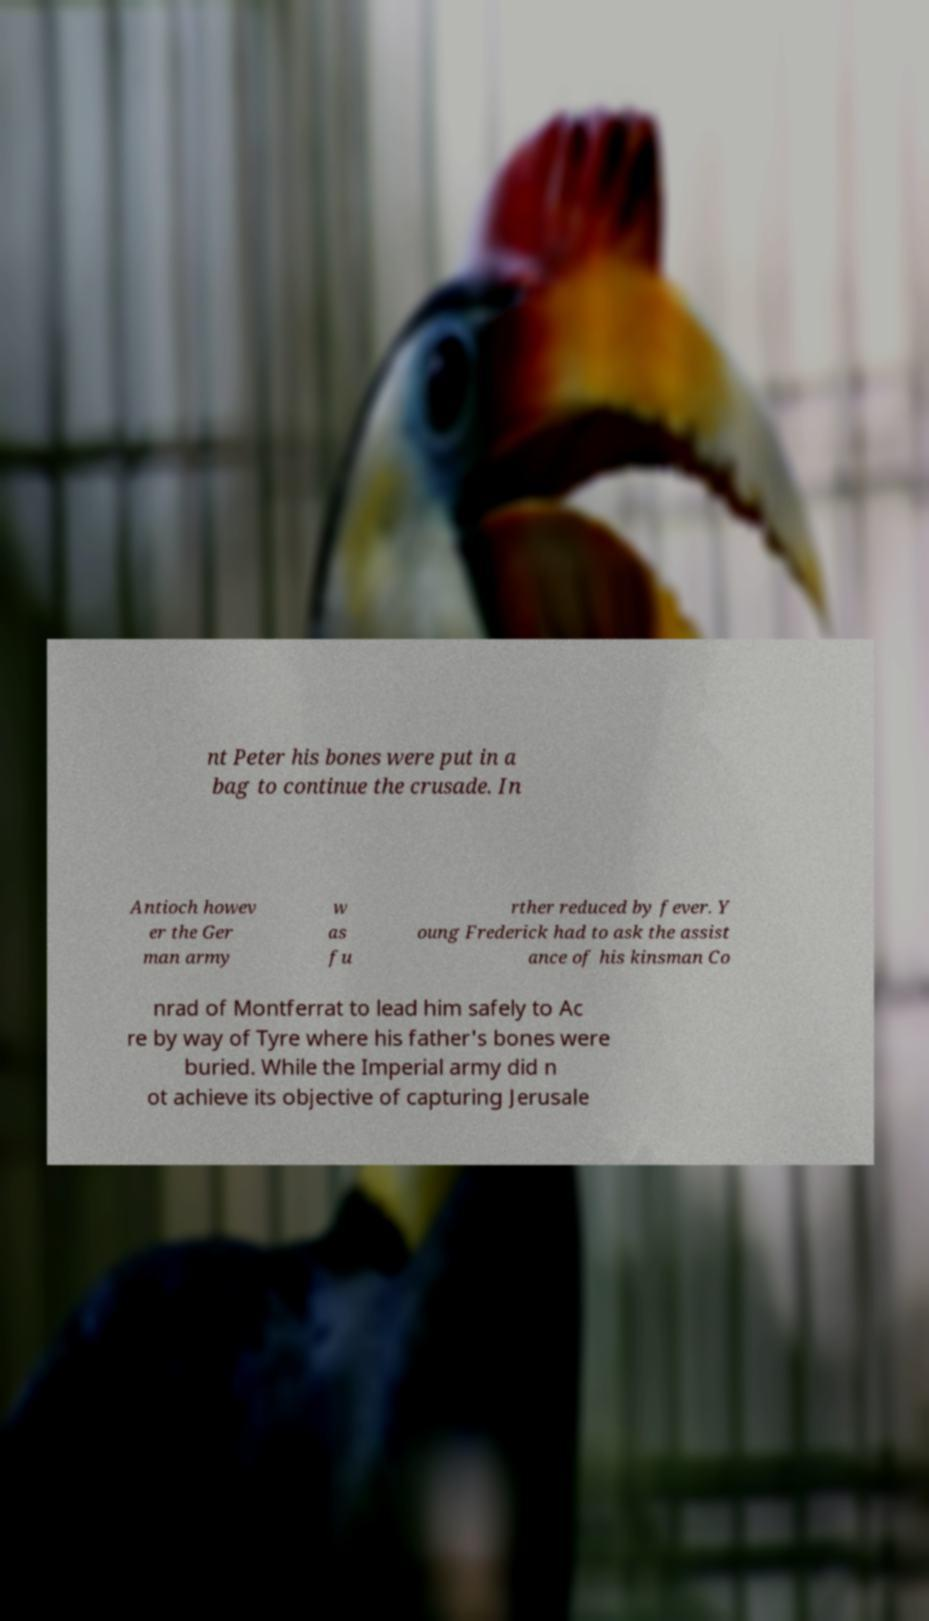Can you read and provide the text displayed in the image?This photo seems to have some interesting text. Can you extract and type it out for me? nt Peter his bones were put in a bag to continue the crusade. In Antioch howev er the Ger man army w as fu rther reduced by fever. Y oung Frederick had to ask the assist ance of his kinsman Co nrad of Montferrat to lead him safely to Ac re by way of Tyre where his father's bones were buried. While the Imperial army did n ot achieve its objective of capturing Jerusale 